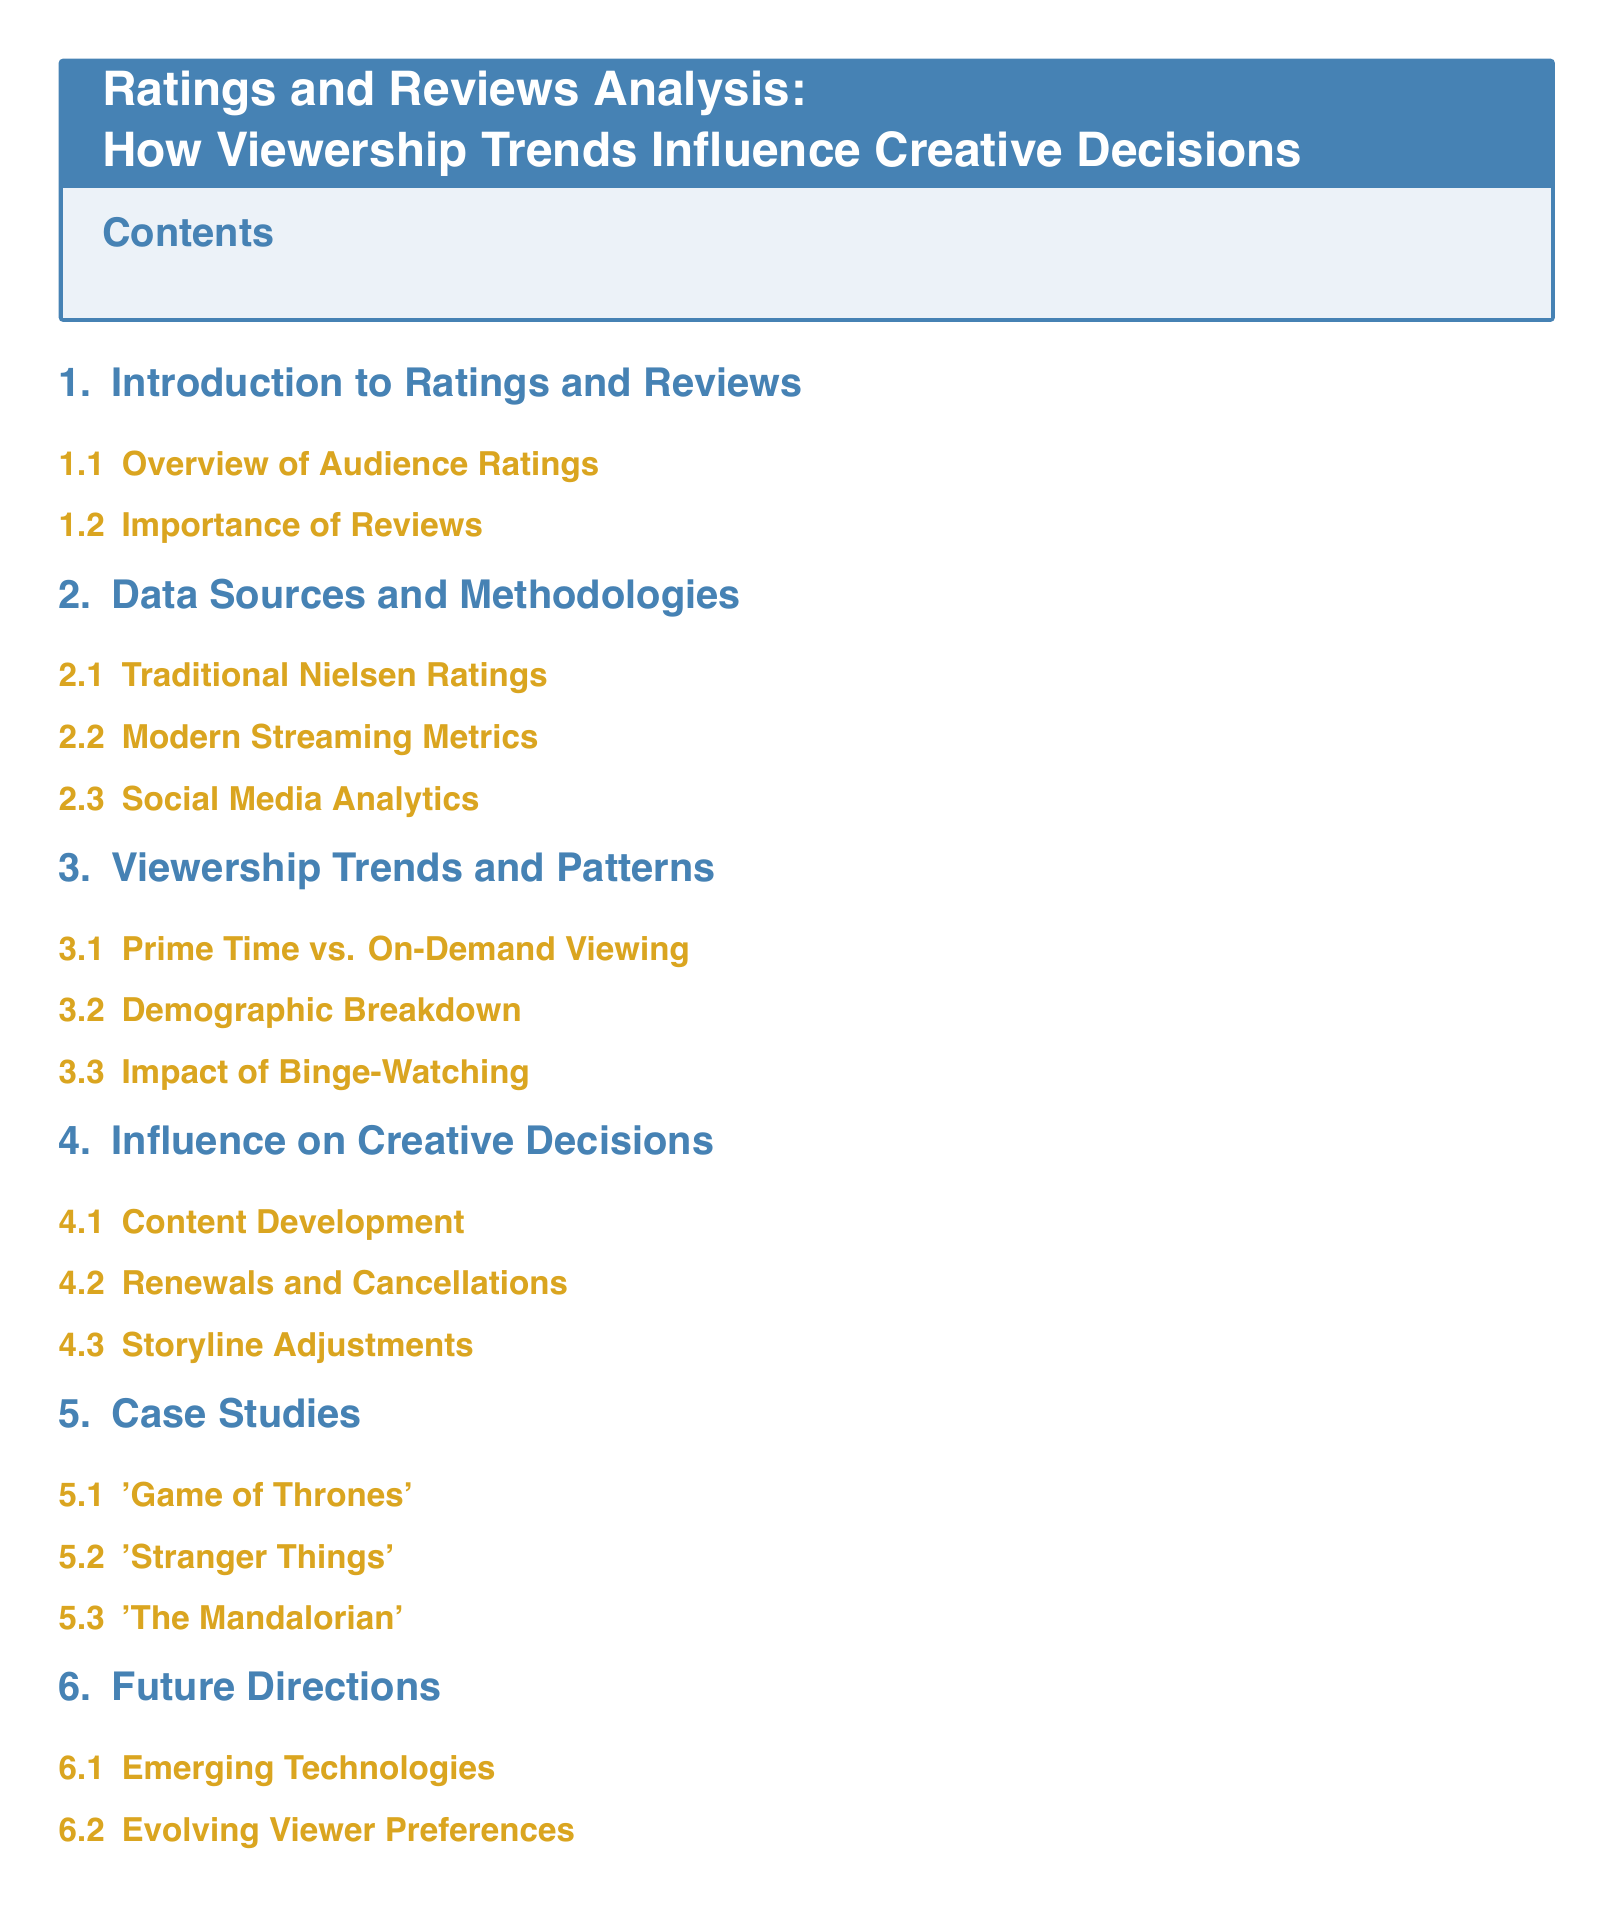What is the title of the document? The title of the document is clearly stated in the title box at the beginning, which is "Ratings and Reviews Analysis: How Viewership Trends Influence Creative Decisions."
Answer: Ratings and Reviews Analysis: How Viewership Trends Influence Creative Decisions How many sections are in the document? The document contains five main sections as listed in the table of contents.
Answer: 5 What is the first subsection under "Influence on Creative Decisions"? The first subsection is listed directly under the "Influence on Creative Decisions" section, which is "Content Development."
Answer: Content Development Which case study is featured last in the document? The last case study listed in the table of contents is found under the "Case Studies" section, and it is "The Mandalorian."
Answer: The Mandalorian What modern metric is discussed under "Data Sources and Methodologies"? The document mentions "Modern Streaming Metrics" as one of the methodologies under this section.
Answer: Modern Streaming Metrics What is emphasized under "Future Directions"? The two subsections listed under "Future Directions" focus on "Emerging Technologies" and "Evolving Viewer Preferences."
Answer: Emerging Technologies What is a key factor influencing viewership trends according to the document? The document addresses multiple factors, but "Impact of Binge-Watching" is noted within "Viewership Trends and Patterns."
Answer: Impact of Binge-Watching 